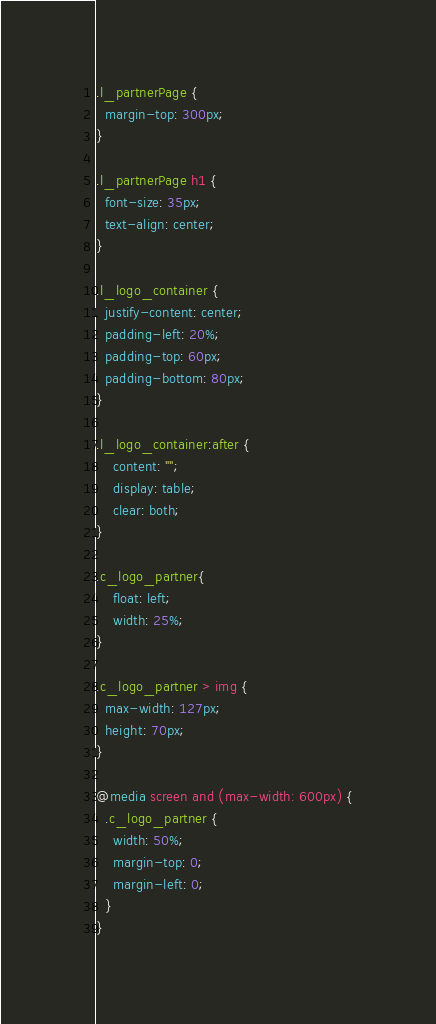Convert code to text. <code><loc_0><loc_0><loc_500><loc_500><_CSS_>.l_partnerPage {
  margin-top: 300px;
}

.l_partnerPage h1 {
  font-size: 35px;
  text-align: center;
}

.l_logo_container {
  justify-content: center;
  padding-left: 20%;
  padding-top: 60px;
  padding-bottom: 80px;
}

.l_logo_container:after {
    content: "";
    display: table;
    clear: both;
}

.c_logo_partner{
    float: left;
    width: 25%;
}

.c_logo_partner > img {
  max-width: 127px;
  height: 70px;
}

@media screen and (max-width: 600px) {
  .c_logo_partner {
    width: 50%;
    margin-top: 0;
    margin-left: 0;
  }
}
</code> 